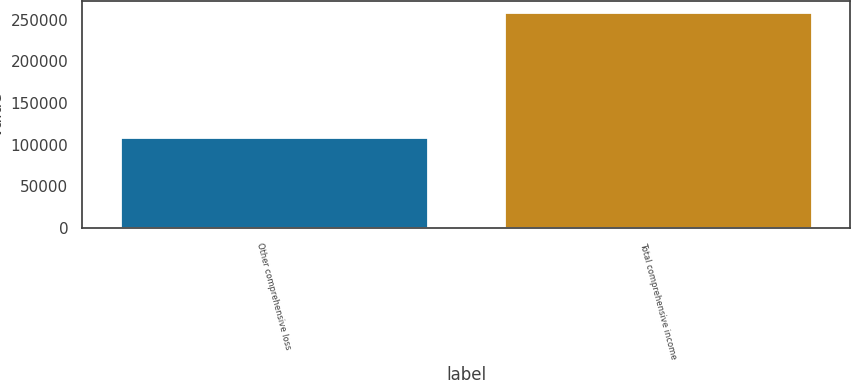<chart> <loc_0><loc_0><loc_500><loc_500><bar_chart><fcel>Other comprehensive loss<fcel>Total comprehensive income<nl><fcel>109507<fcel>259200<nl></chart> 